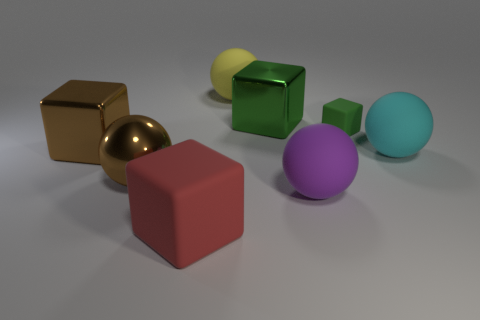Add 1 shiny blocks. How many objects exist? 9 Subtract 0 gray cylinders. How many objects are left? 8 Subtract all big purple shiny blocks. Subtract all large brown objects. How many objects are left? 6 Add 5 brown shiny spheres. How many brown shiny spheres are left? 6 Add 1 yellow spheres. How many yellow spheres exist? 2 